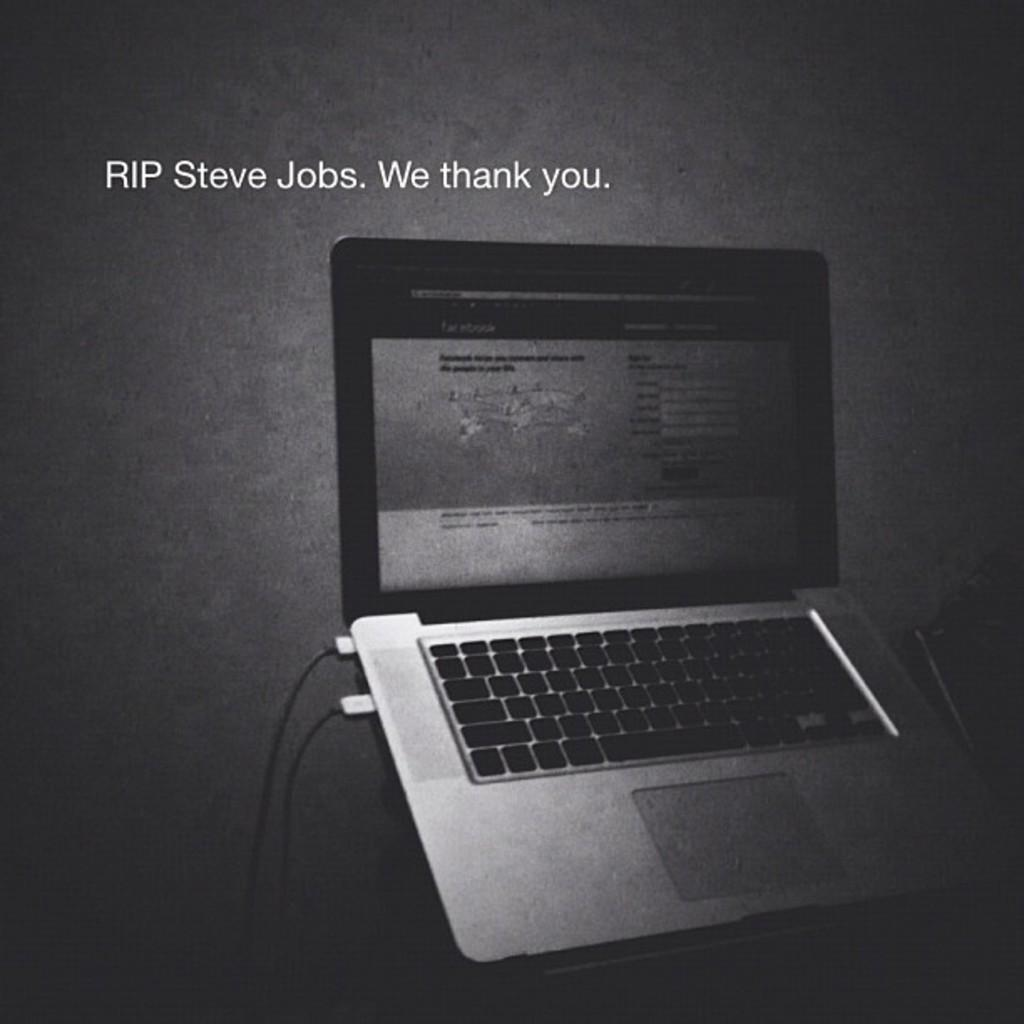Provide a one-sentence caption for the provided image. An open laptop sits below copy referencing Steve Job's death. 